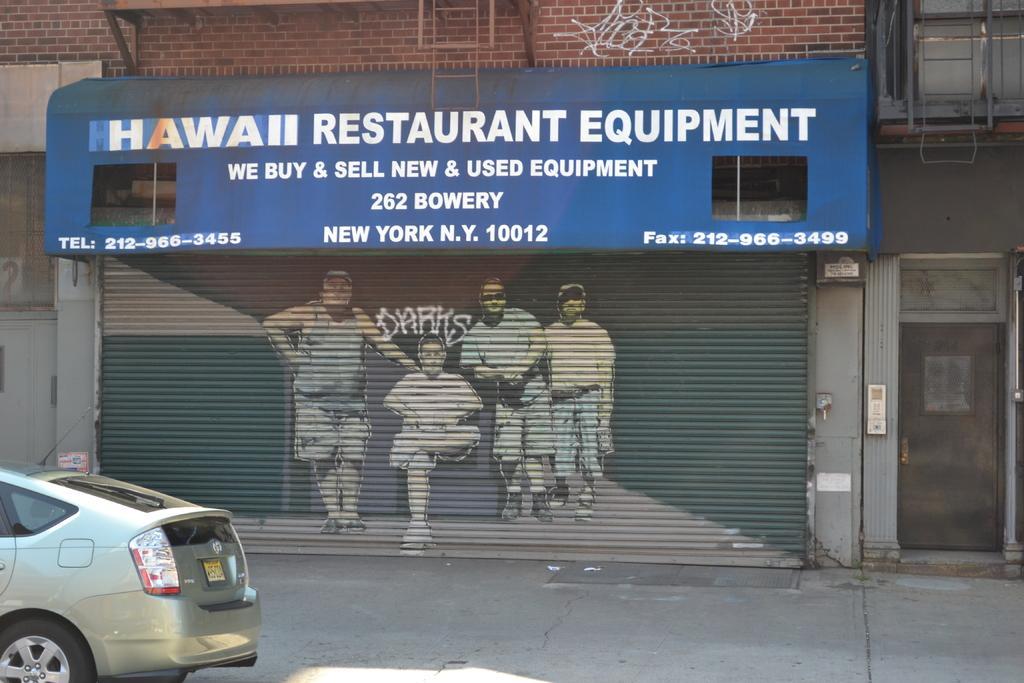Describe this image in one or two sentences. In the image there is a store shutter in the back with painting of men on it, in the front there is a car going on the road. 